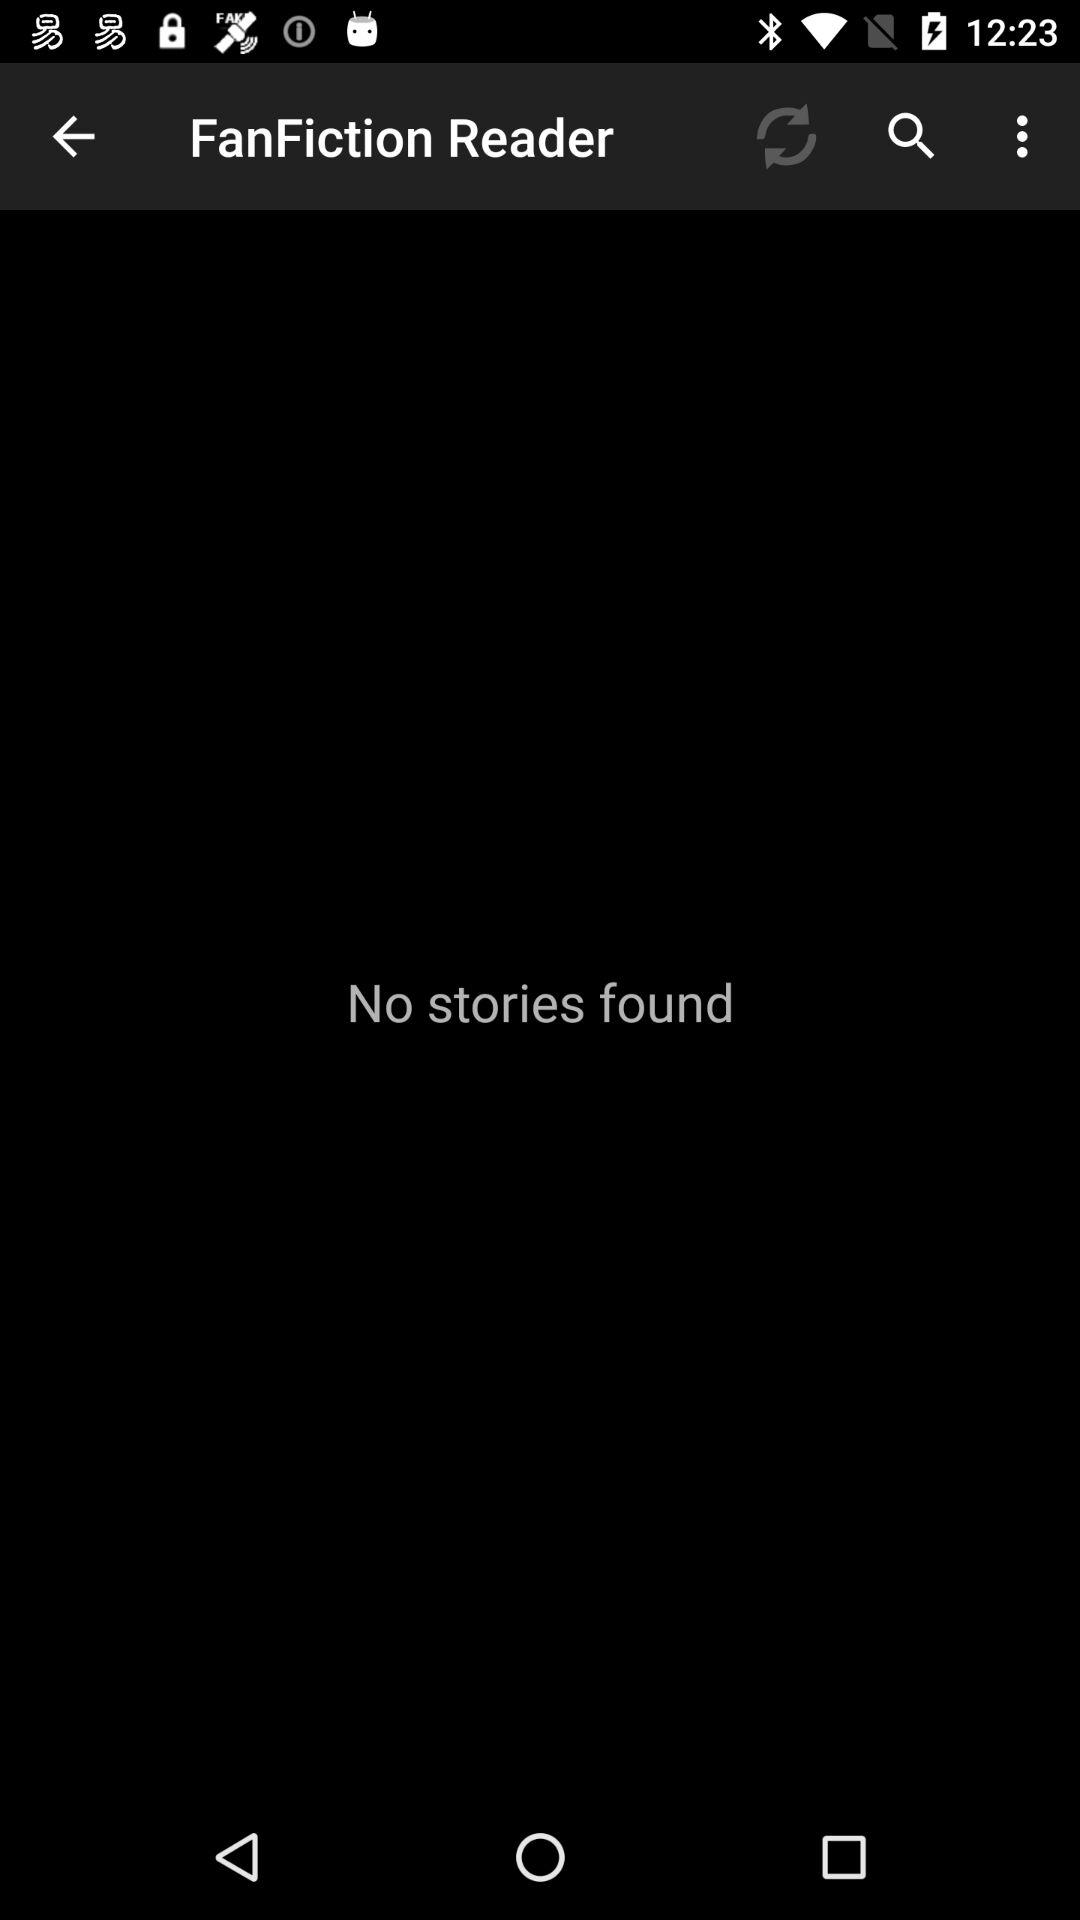What's the Number of Stories?
When the provided information is insufficient, respond with <no answer>. <no answer> 